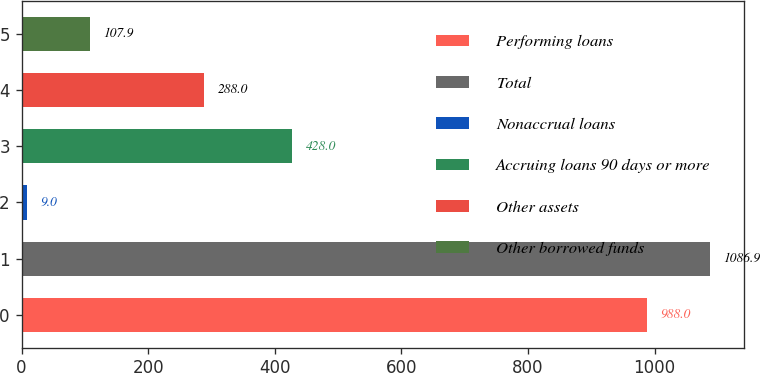<chart> <loc_0><loc_0><loc_500><loc_500><bar_chart><fcel>Performing loans<fcel>Total<fcel>Nonaccrual loans<fcel>Accruing loans 90 days or more<fcel>Other assets<fcel>Other borrowed funds<nl><fcel>988<fcel>1086.9<fcel>9<fcel>428<fcel>288<fcel>107.9<nl></chart> 